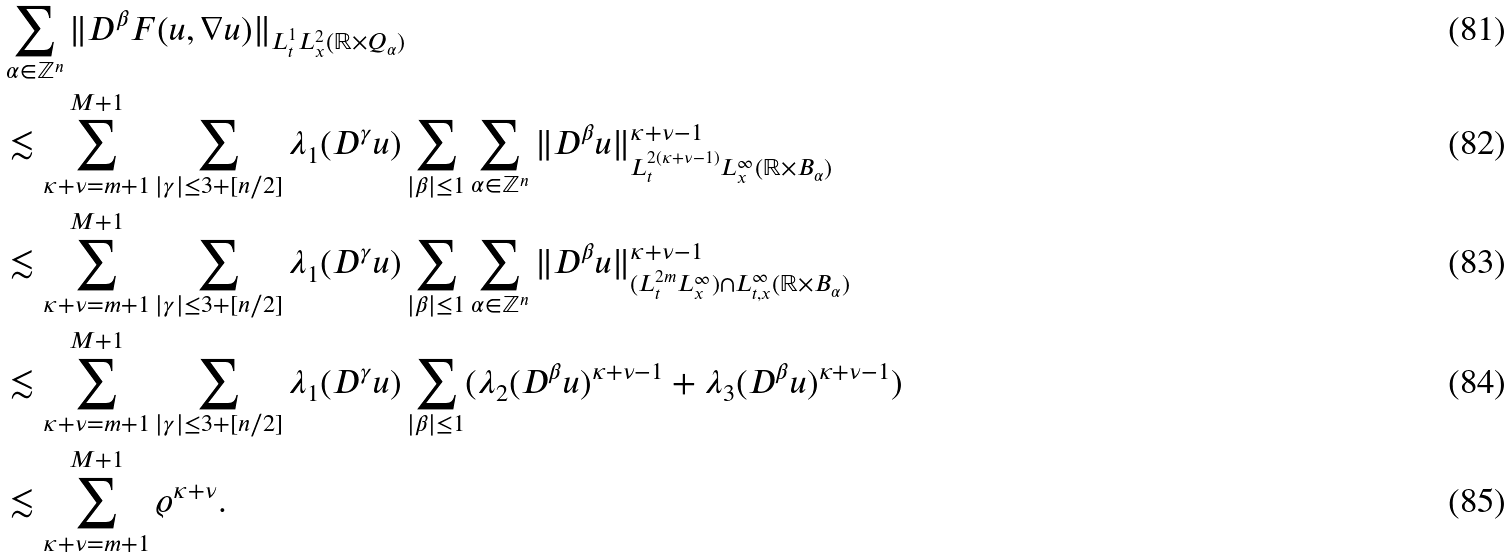<formula> <loc_0><loc_0><loc_500><loc_500>& \sum _ { \alpha \in \mathbb { Z } ^ { n } } \| D ^ { \beta } F ( u , \nabla u ) \| _ { L ^ { 1 } _ { t } L ^ { 2 } _ { x } ( \mathbb { R } \times Q _ { \alpha } ) } \\ & \lesssim \sum ^ { M + 1 } _ { \kappa + \nu = m + 1 } \sum _ { | \gamma | \leq 3 + [ n / 2 ] } \lambda _ { 1 } ( D ^ { \gamma } u ) \sum _ { | \beta | \leq 1 } \sum _ { \alpha \in \mathbb { Z } ^ { n } } \| D ^ { \beta } u \| ^ { \kappa + \nu - 1 } _ { L ^ { 2 ( \kappa + \nu - 1 ) } _ { t } L ^ { \infty } _ { x } ( \mathbb { R } \times B _ { \alpha } ) } \\ & \lesssim \sum ^ { M + 1 } _ { \kappa + \nu = m + 1 } \sum _ { | \gamma | \leq 3 + [ n / 2 ] } \lambda _ { 1 } ( D ^ { \gamma } u ) \sum _ { | \beta | \leq 1 } \sum _ { \alpha \in \mathbb { Z } ^ { n } } \| D ^ { \beta } u \| ^ { \kappa + \nu - 1 } _ { ( L ^ { 2 m } _ { t } L ^ { \infty } _ { x } ) \cap L ^ { \infty } _ { t , x } ( \mathbb { R } \times B _ { \alpha } ) } \\ & \lesssim \sum ^ { M + 1 } _ { \kappa + \nu = m + 1 } \sum _ { | \gamma | \leq 3 + [ n / 2 ] } \lambda _ { 1 } ( D ^ { \gamma } u ) \sum _ { | \beta | \leq 1 } ( \lambda _ { 2 } ( D ^ { \beta } u ) ^ { \kappa + \nu - 1 } + \lambda _ { 3 } ( D ^ { \beta } u ) ^ { \kappa + \nu - 1 } ) \\ & \lesssim \sum ^ { M + 1 } _ { \kappa + \nu = m + 1 } \varrho ^ { \kappa + \nu } .</formula> 